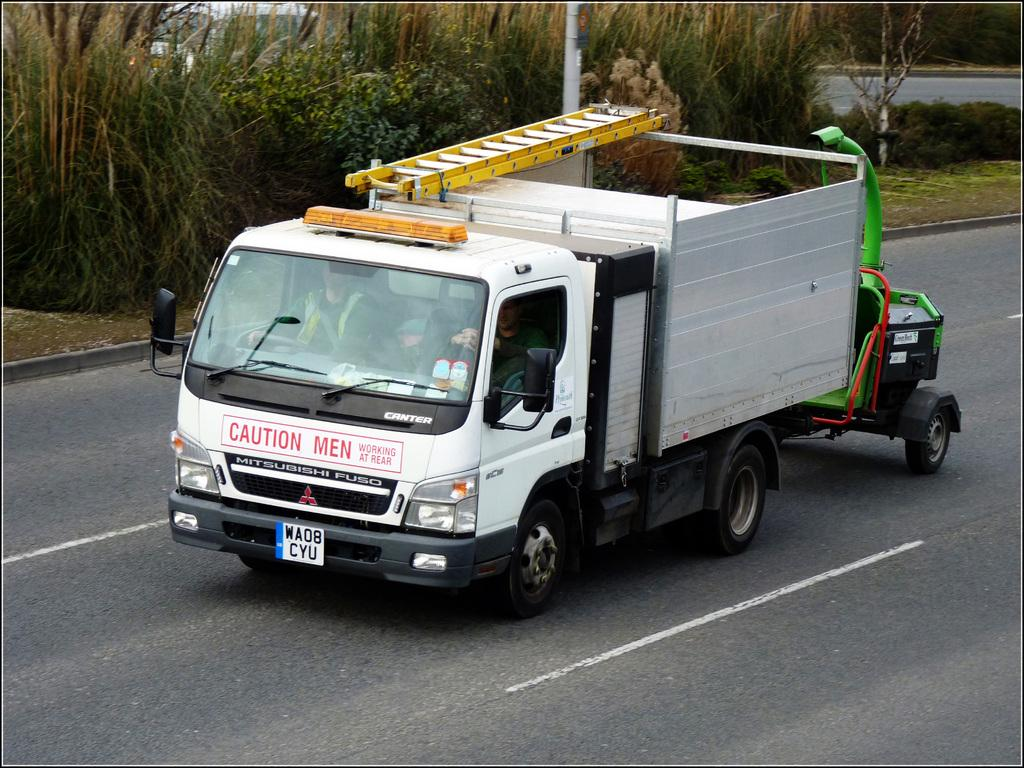What is the main subject of the image? There is a vehicle on the road in the image. What else can be seen in the image besides the vehicle? Plants are visible in the image. Can you describe the background of the image? There is another vehicle in the background of the image. Can you see a bee collecting nectar from the plants in the image? There is no bee present in the image. 